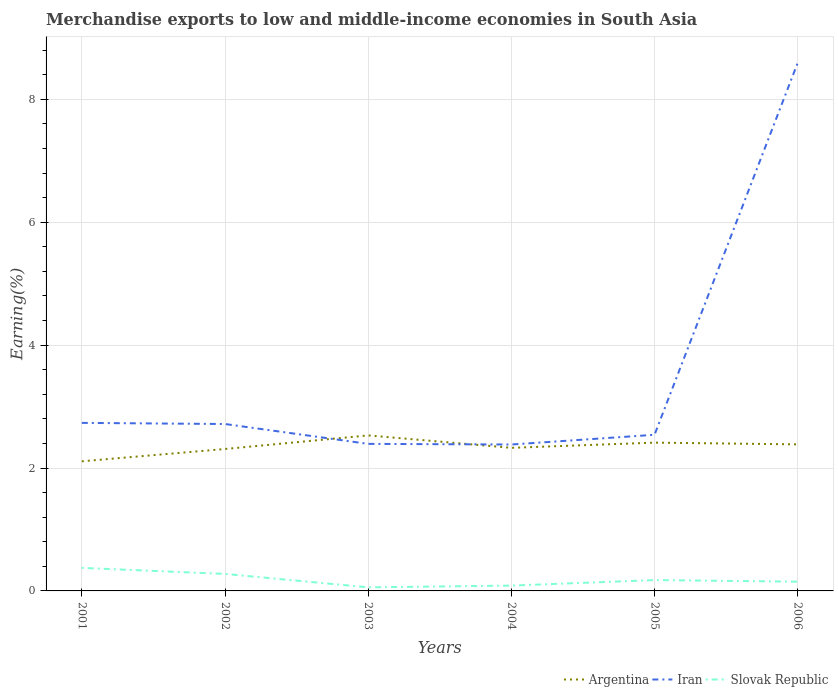Does the line corresponding to Iran intersect with the line corresponding to Argentina?
Give a very brief answer. Yes. Across all years, what is the maximum percentage of amount earned from merchandise exports in Iran?
Provide a succinct answer. 2.38. In which year was the percentage of amount earned from merchandise exports in Iran maximum?
Give a very brief answer. 2004. What is the total percentage of amount earned from merchandise exports in Argentina in the graph?
Offer a terse response. -0.2. What is the difference between the highest and the second highest percentage of amount earned from merchandise exports in Argentina?
Ensure brevity in your answer.  0.42. What is the difference between the highest and the lowest percentage of amount earned from merchandise exports in Slovak Republic?
Offer a terse response. 2. Is the percentage of amount earned from merchandise exports in Slovak Republic strictly greater than the percentage of amount earned from merchandise exports in Iran over the years?
Offer a terse response. Yes. How many years are there in the graph?
Offer a terse response. 6. What is the difference between two consecutive major ticks on the Y-axis?
Offer a very short reply. 2. Are the values on the major ticks of Y-axis written in scientific E-notation?
Your response must be concise. No. What is the title of the graph?
Your answer should be compact. Merchandise exports to low and middle-income economies in South Asia. Does "St. Kitts and Nevis" appear as one of the legend labels in the graph?
Your answer should be very brief. No. What is the label or title of the Y-axis?
Offer a very short reply. Earning(%). What is the Earning(%) in Argentina in 2001?
Your answer should be very brief. 2.11. What is the Earning(%) in Iran in 2001?
Make the answer very short. 2.73. What is the Earning(%) of Slovak Republic in 2001?
Give a very brief answer. 0.37. What is the Earning(%) in Argentina in 2002?
Your response must be concise. 2.31. What is the Earning(%) of Iran in 2002?
Give a very brief answer. 2.72. What is the Earning(%) in Slovak Republic in 2002?
Keep it short and to the point. 0.28. What is the Earning(%) of Argentina in 2003?
Make the answer very short. 2.53. What is the Earning(%) in Iran in 2003?
Ensure brevity in your answer.  2.39. What is the Earning(%) of Slovak Republic in 2003?
Provide a succinct answer. 0.06. What is the Earning(%) of Argentina in 2004?
Your answer should be very brief. 2.33. What is the Earning(%) of Iran in 2004?
Your response must be concise. 2.38. What is the Earning(%) of Slovak Republic in 2004?
Offer a terse response. 0.09. What is the Earning(%) in Argentina in 2005?
Keep it short and to the point. 2.41. What is the Earning(%) in Iran in 2005?
Offer a terse response. 2.54. What is the Earning(%) in Slovak Republic in 2005?
Your response must be concise. 0.18. What is the Earning(%) of Argentina in 2006?
Give a very brief answer. 2.38. What is the Earning(%) of Iran in 2006?
Offer a terse response. 8.59. What is the Earning(%) of Slovak Republic in 2006?
Provide a short and direct response. 0.15. Across all years, what is the maximum Earning(%) in Argentina?
Your answer should be very brief. 2.53. Across all years, what is the maximum Earning(%) in Iran?
Your answer should be very brief. 8.59. Across all years, what is the maximum Earning(%) in Slovak Republic?
Provide a succinct answer. 0.37. Across all years, what is the minimum Earning(%) in Argentina?
Ensure brevity in your answer.  2.11. Across all years, what is the minimum Earning(%) in Iran?
Give a very brief answer. 2.38. Across all years, what is the minimum Earning(%) of Slovak Republic?
Your answer should be very brief. 0.06. What is the total Earning(%) of Argentina in the graph?
Your answer should be very brief. 14.07. What is the total Earning(%) in Iran in the graph?
Make the answer very short. 21.36. What is the total Earning(%) of Slovak Republic in the graph?
Make the answer very short. 1.12. What is the difference between the Earning(%) in Argentina in 2001 and that in 2002?
Your answer should be very brief. -0.2. What is the difference between the Earning(%) in Iran in 2001 and that in 2002?
Your response must be concise. 0.02. What is the difference between the Earning(%) of Slovak Republic in 2001 and that in 2002?
Keep it short and to the point. 0.1. What is the difference between the Earning(%) in Argentina in 2001 and that in 2003?
Keep it short and to the point. -0.42. What is the difference between the Earning(%) in Iran in 2001 and that in 2003?
Offer a very short reply. 0.34. What is the difference between the Earning(%) in Slovak Republic in 2001 and that in 2003?
Ensure brevity in your answer.  0.32. What is the difference between the Earning(%) of Argentina in 2001 and that in 2004?
Ensure brevity in your answer.  -0.22. What is the difference between the Earning(%) in Iran in 2001 and that in 2004?
Give a very brief answer. 0.35. What is the difference between the Earning(%) of Slovak Republic in 2001 and that in 2004?
Provide a short and direct response. 0.29. What is the difference between the Earning(%) in Argentina in 2001 and that in 2005?
Keep it short and to the point. -0.3. What is the difference between the Earning(%) of Iran in 2001 and that in 2005?
Provide a short and direct response. 0.19. What is the difference between the Earning(%) of Slovak Republic in 2001 and that in 2005?
Your answer should be very brief. 0.2. What is the difference between the Earning(%) in Argentina in 2001 and that in 2006?
Your answer should be very brief. -0.28. What is the difference between the Earning(%) of Iran in 2001 and that in 2006?
Ensure brevity in your answer.  -5.86. What is the difference between the Earning(%) in Slovak Republic in 2001 and that in 2006?
Make the answer very short. 0.22. What is the difference between the Earning(%) of Argentina in 2002 and that in 2003?
Your answer should be very brief. -0.22. What is the difference between the Earning(%) in Iran in 2002 and that in 2003?
Offer a terse response. 0.32. What is the difference between the Earning(%) in Slovak Republic in 2002 and that in 2003?
Provide a succinct answer. 0.22. What is the difference between the Earning(%) of Argentina in 2002 and that in 2004?
Provide a short and direct response. -0.02. What is the difference between the Earning(%) in Iran in 2002 and that in 2004?
Ensure brevity in your answer.  0.33. What is the difference between the Earning(%) of Slovak Republic in 2002 and that in 2004?
Ensure brevity in your answer.  0.19. What is the difference between the Earning(%) of Argentina in 2002 and that in 2005?
Offer a very short reply. -0.1. What is the difference between the Earning(%) in Iran in 2002 and that in 2005?
Make the answer very short. 0.18. What is the difference between the Earning(%) of Slovak Republic in 2002 and that in 2005?
Make the answer very short. 0.1. What is the difference between the Earning(%) in Argentina in 2002 and that in 2006?
Your answer should be compact. -0.08. What is the difference between the Earning(%) in Iran in 2002 and that in 2006?
Offer a terse response. -5.88. What is the difference between the Earning(%) of Slovak Republic in 2002 and that in 2006?
Keep it short and to the point. 0.13. What is the difference between the Earning(%) of Argentina in 2003 and that in 2004?
Your answer should be very brief. 0.2. What is the difference between the Earning(%) in Iran in 2003 and that in 2004?
Keep it short and to the point. 0.01. What is the difference between the Earning(%) of Slovak Republic in 2003 and that in 2004?
Ensure brevity in your answer.  -0.03. What is the difference between the Earning(%) in Argentina in 2003 and that in 2005?
Ensure brevity in your answer.  0.12. What is the difference between the Earning(%) of Iran in 2003 and that in 2005?
Your response must be concise. -0.15. What is the difference between the Earning(%) of Slovak Republic in 2003 and that in 2005?
Your response must be concise. -0.12. What is the difference between the Earning(%) of Argentina in 2003 and that in 2006?
Provide a short and direct response. 0.15. What is the difference between the Earning(%) in Iran in 2003 and that in 2006?
Offer a terse response. -6.2. What is the difference between the Earning(%) of Slovak Republic in 2003 and that in 2006?
Your answer should be compact. -0.09. What is the difference between the Earning(%) of Argentina in 2004 and that in 2005?
Your answer should be very brief. -0.08. What is the difference between the Earning(%) in Iran in 2004 and that in 2005?
Provide a succinct answer. -0.16. What is the difference between the Earning(%) in Slovak Republic in 2004 and that in 2005?
Your answer should be compact. -0.09. What is the difference between the Earning(%) in Argentina in 2004 and that in 2006?
Give a very brief answer. -0.06. What is the difference between the Earning(%) in Iran in 2004 and that in 2006?
Keep it short and to the point. -6.21. What is the difference between the Earning(%) in Slovak Republic in 2004 and that in 2006?
Provide a succinct answer. -0.06. What is the difference between the Earning(%) of Argentina in 2005 and that in 2006?
Provide a short and direct response. 0.03. What is the difference between the Earning(%) in Iran in 2005 and that in 2006?
Your answer should be very brief. -6.05. What is the difference between the Earning(%) of Slovak Republic in 2005 and that in 2006?
Your answer should be very brief. 0.03. What is the difference between the Earning(%) in Argentina in 2001 and the Earning(%) in Iran in 2002?
Offer a very short reply. -0.61. What is the difference between the Earning(%) in Argentina in 2001 and the Earning(%) in Slovak Republic in 2002?
Make the answer very short. 1.83. What is the difference between the Earning(%) of Iran in 2001 and the Earning(%) of Slovak Republic in 2002?
Keep it short and to the point. 2.46. What is the difference between the Earning(%) in Argentina in 2001 and the Earning(%) in Iran in 2003?
Keep it short and to the point. -0.28. What is the difference between the Earning(%) in Argentina in 2001 and the Earning(%) in Slovak Republic in 2003?
Provide a succinct answer. 2.05. What is the difference between the Earning(%) of Iran in 2001 and the Earning(%) of Slovak Republic in 2003?
Keep it short and to the point. 2.68. What is the difference between the Earning(%) of Argentina in 2001 and the Earning(%) of Iran in 2004?
Provide a short and direct response. -0.27. What is the difference between the Earning(%) of Argentina in 2001 and the Earning(%) of Slovak Republic in 2004?
Offer a very short reply. 2.02. What is the difference between the Earning(%) of Iran in 2001 and the Earning(%) of Slovak Republic in 2004?
Your answer should be compact. 2.65. What is the difference between the Earning(%) in Argentina in 2001 and the Earning(%) in Iran in 2005?
Make the answer very short. -0.43. What is the difference between the Earning(%) of Argentina in 2001 and the Earning(%) of Slovak Republic in 2005?
Keep it short and to the point. 1.93. What is the difference between the Earning(%) of Iran in 2001 and the Earning(%) of Slovak Republic in 2005?
Offer a terse response. 2.56. What is the difference between the Earning(%) in Argentina in 2001 and the Earning(%) in Iran in 2006?
Make the answer very short. -6.48. What is the difference between the Earning(%) in Argentina in 2001 and the Earning(%) in Slovak Republic in 2006?
Provide a succinct answer. 1.96. What is the difference between the Earning(%) of Iran in 2001 and the Earning(%) of Slovak Republic in 2006?
Ensure brevity in your answer.  2.58. What is the difference between the Earning(%) of Argentina in 2002 and the Earning(%) of Iran in 2003?
Your answer should be very brief. -0.08. What is the difference between the Earning(%) in Argentina in 2002 and the Earning(%) in Slovak Republic in 2003?
Ensure brevity in your answer.  2.25. What is the difference between the Earning(%) in Iran in 2002 and the Earning(%) in Slovak Republic in 2003?
Keep it short and to the point. 2.66. What is the difference between the Earning(%) in Argentina in 2002 and the Earning(%) in Iran in 2004?
Offer a very short reply. -0.07. What is the difference between the Earning(%) of Argentina in 2002 and the Earning(%) of Slovak Republic in 2004?
Keep it short and to the point. 2.22. What is the difference between the Earning(%) of Iran in 2002 and the Earning(%) of Slovak Republic in 2004?
Ensure brevity in your answer.  2.63. What is the difference between the Earning(%) in Argentina in 2002 and the Earning(%) in Iran in 2005?
Offer a very short reply. -0.23. What is the difference between the Earning(%) in Argentina in 2002 and the Earning(%) in Slovak Republic in 2005?
Your answer should be compact. 2.13. What is the difference between the Earning(%) of Iran in 2002 and the Earning(%) of Slovak Republic in 2005?
Provide a short and direct response. 2.54. What is the difference between the Earning(%) of Argentina in 2002 and the Earning(%) of Iran in 2006?
Offer a terse response. -6.28. What is the difference between the Earning(%) in Argentina in 2002 and the Earning(%) in Slovak Republic in 2006?
Your answer should be very brief. 2.16. What is the difference between the Earning(%) in Iran in 2002 and the Earning(%) in Slovak Republic in 2006?
Give a very brief answer. 2.57. What is the difference between the Earning(%) of Argentina in 2003 and the Earning(%) of Iran in 2004?
Keep it short and to the point. 0.15. What is the difference between the Earning(%) of Argentina in 2003 and the Earning(%) of Slovak Republic in 2004?
Offer a terse response. 2.44. What is the difference between the Earning(%) in Iran in 2003 and the Earning(%) in Slovak Republic in 2004?
Offer a very short reply. 2.31. What is the difference between the Earning(%) of Argentina in 2003 and the Earning(%) of Iran in 2005?
Your response must be concise. -0.01. What is the difference between the Earning(%) in Argentina in 2003 and the Earning(%) in Slovak Republic in 2005?
Offer a very short reply. 2.35. What is the difference between the Earning(%) of Iran in 2003 and the Earning(%) of Slovak Republic in 2005?
Offer a terse response. 2.22. What is the difference between the Earning(%) in Argentina in 2003 and the Earning(%) in Iran in 2006?
Offer a terse response. -6.06. What is the difference between the Earning(%) of Argentina in 2003 and the Earning(%) of Slovak Republic in 2006?
Provide a short and direct response. 2.38. What is the difference between the Earning(%) of Iran in 2003 and the Earning(%) of Slovak Republic in 2006?
Provide a short and direct response. 2.24. What is the difference between the Earning(%) of Argentina in 2004 and the Earning(%) of Iran in 2005?
Keep it short and to the point. -0.21. What is the difference between the Earning(%) of Argentina in 2004 and the Earning(%) of Slovak Republic in 2005?
Provide a succinct answer. 2.15. What is the difference between the Earning(%) of Iran in 2004 and the Earning(%) of Slovak Republic in 2005?
Your answer should be compact. 2.21. What is the difference between the Earning(%) of Argentina in 2004 and the Earning(%) of Iran in 2006?
Your answer should be very brief. -6.26. What is the difference between the Earning(%) of Argentina in 2004 and the Earning(%) of Slovak Republic in 2006?
Your answer should be very brief. 2.18. What is the difference between the Earning(%) in Iran in 2004 and the Earning(%) in Slovak Republic in 2006?
Your response must be concise. 2.23. What is the difference between the Earning(%) in Argentina in 2005 and the Earning(%) in Iran in 2006?
Provide a short and direct response. -6.18. What is the difference between the Earning(%) in Argentina in 2005 and the Earning(%) in Slovak Republic in 2006?
Keep it short and to the point. 2.26. What is the difference between the Earning(%) of Iran in 2005 and the Earning(%) of Slovak Republic in 2006?
Your response must be concise. 2.39. What is the average Earning(%) of Argentina per year?
Your response must be concise. 2.35. What is the average Earning(%) of Iran per year?
Offer a very short reply. 3.56. What is the average Earning(%) of Slovak Republic per year?
Your answer should be compact. 0.19. In the year 2001, what is the difference between the Earning(%) of Argentina and Earning(%) of Iran?
Ensure brevity in your answer.  -0.63. In the year 2001, what is the difference between the Earning(%) in Argentina and Earning(%) in Slovak Republic?
Your response must be concise. 1.73. In the year 2001, what is the difference between the Earning(%) of Iran and Earning(%) of Slovak Republic?
Keep it short and to the point. 2.36. In the year 2002, what is the difference between the Earning(%) in Argentina and Earning(%) in Iran?
Keep it short and to the point. -0.41. In the year 2002, what is the difference between the Earning(%) in Argentina and Earning(%) in Slovak Republic?
Keep it short and to the point. 2.03. In the year 2002, what is the difference between the Earning(%) of Iran and Earning(%) of Slovak Republic?
Ensure brevity in your answer.  2.44. In the year 2003, what is the difference between the Earning(%) of Argentina and Earning(%) of Iran?
Give a very brief answer. 0.14. In the year 2003, what is the difference between the Earning(%) of Argentina and Earning(%) of Slovak Republic?
Ensure brevity in your answer.  2.47. In the year 2003, what is the difference between the Earning(%) of Iran and Earning(%) of Slovak Republic?
Provide a short and direct response. 2.33. In the year 2004, what is the difference between the Earning(%) in Argentina and Earning(%) in Iran?
Make the answer very short. -0.05. In the year 2004, what is the difference between the Earning(%) in Argentina and Earning(%) in Slovak Republic?
Ensure brevity in your answer.  2.24. In the year 2004, what is the difference between the Earning(%) in Iran and Earning(%) in Slovak Republic?
Your answer should be very brief. 2.3. In the year 2005, what is the difference between the Earning(%) in Argentina and Earning(%) in Iran?
Provide a succinct answer. -0.13. In the year 2005, what is the difference between the Earning(%) in Argentina and Earning(%) in Slovak Republic?
Your answer should be very brief. 2.24. In the year 2005, what is the difference between the Earning(%) in Iran and Earning(%) in Slovak Republic?
Your response must be concise. 2.36. In the year 2006, what is the difference between the Earning(%) of Argentina and Earning(%) of Iran?
Keep it short and to the point. -6.21. In the year 2006, what is the difference between the Earning(%) in Argentina and Earning(%) in Slovak Republic?
Provide a short and direct response. 2.23. In the year 2006, what is the difference between the Earning(%) in Iran and Earning(%) in Slovak Republic?
Give a very brief answer. 8.44. What is the ratio of the Earning(%) in Argentina in 2001 to that in 2002?
Provide a succinct answer. 0.91. What is the ratio of the Earning(%) in Iran in 2001 to that in 2002?
Your answer should be compact. 1.01. What is the ratio of the Earning(%) of Slovak Republic in 2001 to that in 2002?
Your response must be concise. 1.36. What is the ratio of the Earning(%) in Argentina in 2001 to that in 2003?
Ensure brevity in your answer.  0.83. What is the ratio of the Earning(%) of Iran in 2001 to that in 2003?
Ensure brevity in your answer.  1.14. What is the ratio of the Earning(%) in Slovak Republic in 2001 to that in 2003?
Make the answer very short. 6.42. What is the ratio of the Earning(%) of Argentina in 2001 to that in 2004?
Keep it short and to the point. 0.91. What is the ratio of the Earning(%) in Iran in 2001 to that in 2004?
Offer a very short reply. 1.15. What is the ratio of the Earning(%) in Slovak Republic in 2001 to that in 2004?
Offer a very short reply. 4.32. What is the ratio of the Earning(%) in Argentina in 2001 to that in 2005?
Ensure brevity in your answer.  0.87. What is the ratio of the Earning(%) of Iran in 2001 to that in 2005?
Provide a short and direct response. 1.08. What is the ratio of the Earning(%) of Slovak Republic in 2001 to that in 2005?
Provide a short and direct response. 2.12. What is the ratio of the Earning(%) of Argentina in 2001 to that in 2006?
Provide a succinct answer. 0.88. What is the ratio of the Earning(%) of Iran in 2001 to that in 2006?
Your response must be concise. 0.32. What is the ratio of the Earning(%) of Slovak Republic in 2001 to that in 2006?
Offer a very short reply. 2.49. What is the ratio of the Earning(%) of Argentina in 2002 to that in 2003?
Offer a very short reply. 0.91. What is the ratio of the Earning(%) of Iran in 2002 to that in 2003?
Give a very brief answer. 1.14. What is the ratio of the Earning(%) in Slovak Republic in 2002 to that in 2003?
Make the answer very short. 4.73. What is the ratio of the Earning(%) of Argentina in 2002 to that in 2004?
Keep it short and to the point. 0.99. What is the ratio of the Earning(%) in Iran in 2002 to that in 2004?
Provide a succinct answer. 1.14. What is the ratio of the Earning(%) in Slovak Republic in 2002 to that in 2004?
Keep it short and to the point. 3.19. What is the ratio of the Earning(%) in Argentina in 2002 to that in 2005?
Your answer should be compact. 0.96. What is the ratio of the Earning(%) in Iran in 2002 to that in 2005?
Provide a short and direct response. 1.07. What is the ratio of the Earning(%) in Slovak Republic in 2002 to that in 2005?
Your answer should be compact. 1.57. What is the ratio of the Earning(%) in Argentina in 2002 to that in 2006?
Offer a terse response. 0.97. What is the ratio of the Earning(%) in Iran in 2002 to that in 2006?
Give a very brief answer. 0.32. What is the ratio of the Earning(%) of Slovak Republic in 2002 to that in 2006?
Your response must be concise. 1.84. What is the ratio of the Earning(%) in Argentina in 2003 to that in 2004?
Provide a succinct answer. 1.09. What is the ratio of the Earning(%) in Iran in 2003 to that in 2004?
Your answer should be very brief. 1. What is the ratio of the Earning(%) in Slovak Republic in 2003 to that in 2004?
Your answer should be very brief. 0.67. What is the ratio of the Earning(%) of Argentina in 2003 to that in 2005?
Make the answer very short. 1.05. What is the ratio of the Earning(%) in Iran in 2003 to that in 2005?
Your answer should be compact. 0.94. What is the ratio of the Earning(%) in Slovak Republic in 2003 to that in 2005?
Offer a very short reply. 0.33. What is the ratio of the Earning(%) of Argentina in 2003 to that in 2006?
Your answer should be compact. 1.06. What is the ratio of the Earning(%) of Iran in 2003 to that in 2006?
Offer a very short reply. 0.28. What is the ratio of the Earning(%) in Slovak Republic in 2003 to that in 2006?
Provide a succinct answer. 0.39. What is the ratio of the Earning(%) in Argentina in 2004 to that in 2005?
Make the answer very short. 0.96. What is the ratio of the Earning(%) in Iran in 2004 to that in 2005?
Keep it short and to the point. 0.94. What is the ratio of the Earning(%) in Slovak Republic in 2004 to that in 2005?
Offer a very short reply. 0.49. What is the ratio of the Earning(%) in Argentina in 2004 to that in 2006?
Provide a short and direct response. 0.98. What is the ratio of the Earning(%) of Iran in 2004 to that in 2006?
Provide a succinct answer. 0.28. What is the ratio of the Earning(%) of Slovak Republic in 2004 to that in 2006?
Keep it short and to the point. 0.58. What is the ratio of the Earning(%) of Argentina in 2005 to that in 2006?
Your response must be concise. 1.01. What is the ratio of the Earning(%) in Iran in 2005 to that in 2006?
Keep it short and to the point. 0.3. What is the ratio of the Earning(%) of Slovak Republic in 2005 to that in 2006?
Offer a very short reply. 1.17. What is the difference between the highest and the second highest Earning(%) in Argentina?
Keep it short and to the point. 0.12. What is the difference between the highest and the second highest Earning(%) of Iran?
Your answer should be very brief. 5.86. What is the difference between the highest and the second highest Earning(%) in Slovak Republic?
Provide a succinct answer. 0.1. What is the difference between the highest and the lowest Earning(%) of Argentina?
Keep it short and to the point. 0.42. What is the difference between the highest and the lowest Earning(%) in Iran?
Provide a short and direct response. 6.21. What is the difference between the highest and the lowest Earning(%) in Slovak Republic?
Ensure brevity in your answer.  0.32. 